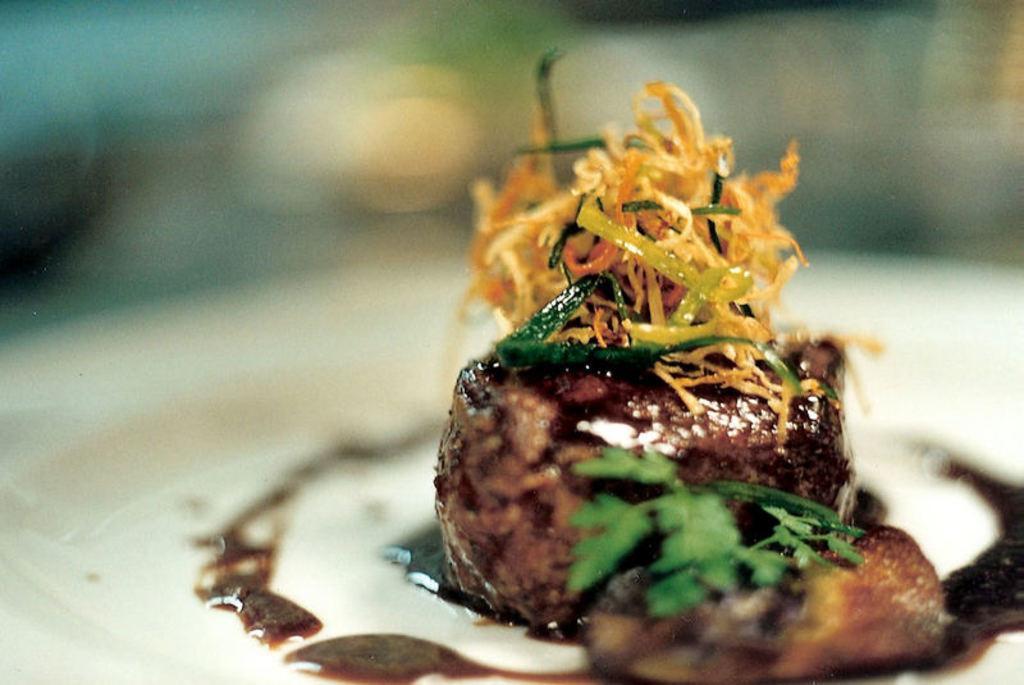Could you give a brief overview of what you see in this image? In the front of the image I can see food on the plate. In the background of the image it is blurry.  